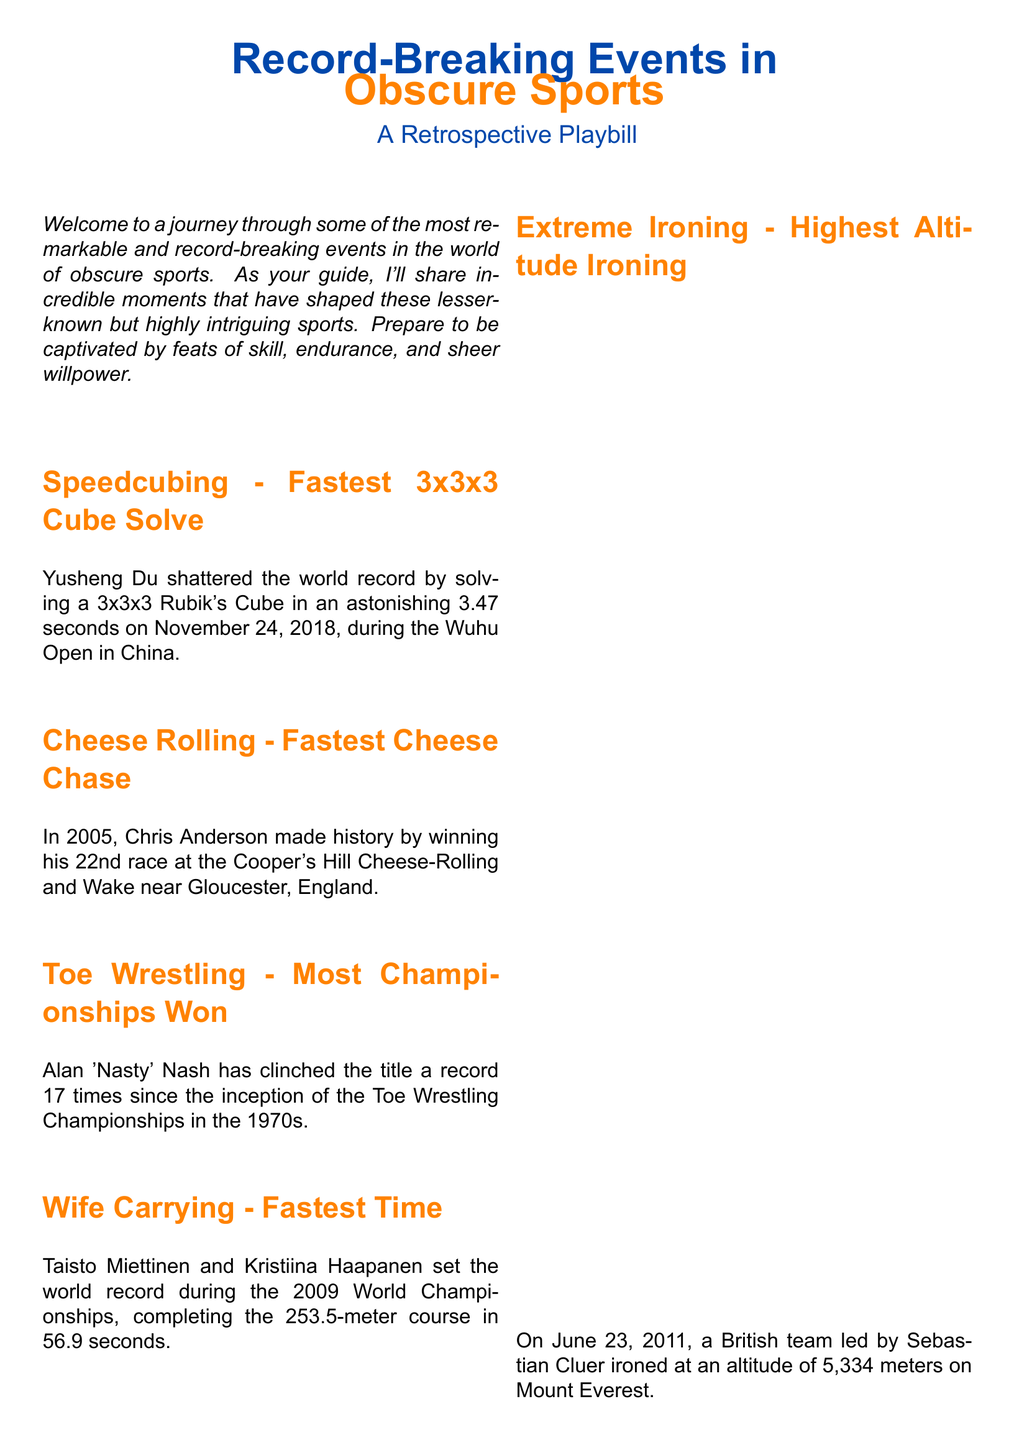What is the fastest time for the 3x3x3 cube solve? Yusheng Du set the record with a time of 3.47 seconds during the Wuhu Open.
Answer: 3.47 seconds Who won the Cheese Rolling race in 2005? Chris Anderson made history by winning his 22nd race at the Cooper's Hill Cheese-Rolling.
Answer: Chris Anderson How many championships has Alan 'Nasty' Nash won in Toe Wrestling? Alan 'Nasty' Nash has won the championship a record 17 times since the 1970s.
Answer: 17 times What was the altitude for the highest ironing event? The British team led by Sebastian Cluer ironed at an altitude of 5,334 meters on Mount Everest.
Answer: 5,334 meters What year was the fastest Wife Carrying time recorded? The world record was set during the 2009 World Championships.
Answer: 2009 What type of event is the Cooper's Hill Cheese-Rolling? The event is known for cheese chasing down a hill.
Answer: Cheese Rolling Which sport features the record held by Taisto Miettinen and Kristiina Haapanen? They set a record in the sport known as Wife Carrying.
Answer: Wife Carrying Who is the guide for the Playbill? The document mentions a guide who shares incredible moments and is referred to generally as "Your Guide."
Answer: Your Guide What is the main focus of the document? The document is a retrospective playbill focusing on record-breaking events in obscure sports.
Answer: Obscure Sports 